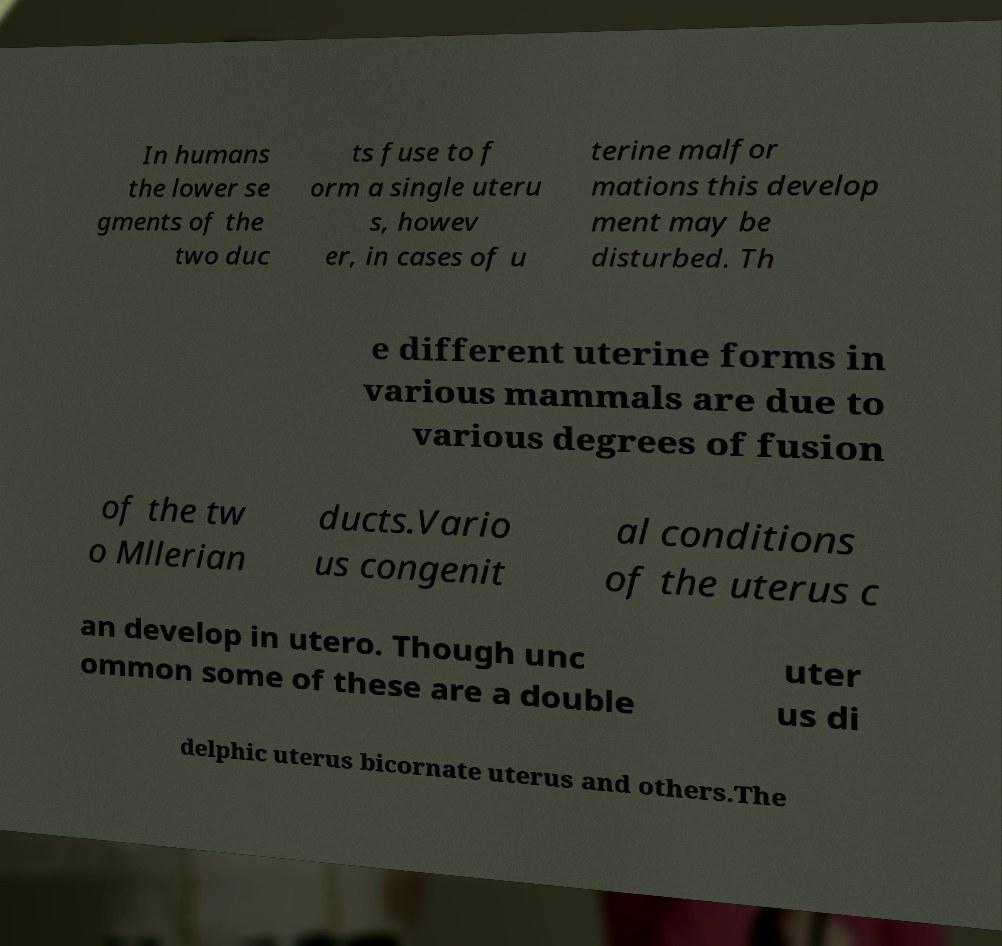I need the written content from this picture converted into text. Can you do that? In humans the lower se gments of the two duc ts fuse to f orm a single uteru s, howev er, in cases of u terine malfor mations this develop ment may be disturbed. Th e different uterine forms in various mammals are due to various degrees of fusion of the tw o Mllerian ducts.Vario us congenit al conditions of the uterus c an develop in utero. Though unc ommon some of these are a double uter us di delphic uterus bicornate uterus and others.The 